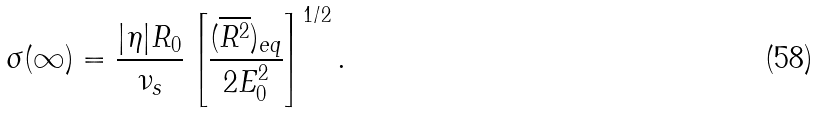Convert formula to latex. <formula><loc_0><loc_0><loc_500><loc_500>\sigma ( \infty ) = \frac { | \eta | R _ { 0 } } { \nu _ { s } } \left [ \frac { ( \overline { R ^ { 2 } } ) _ { e q } } { 2 E _ { 0 } ^ { 2 } } \right ] ^ { 1 / 2 } .</formula> 